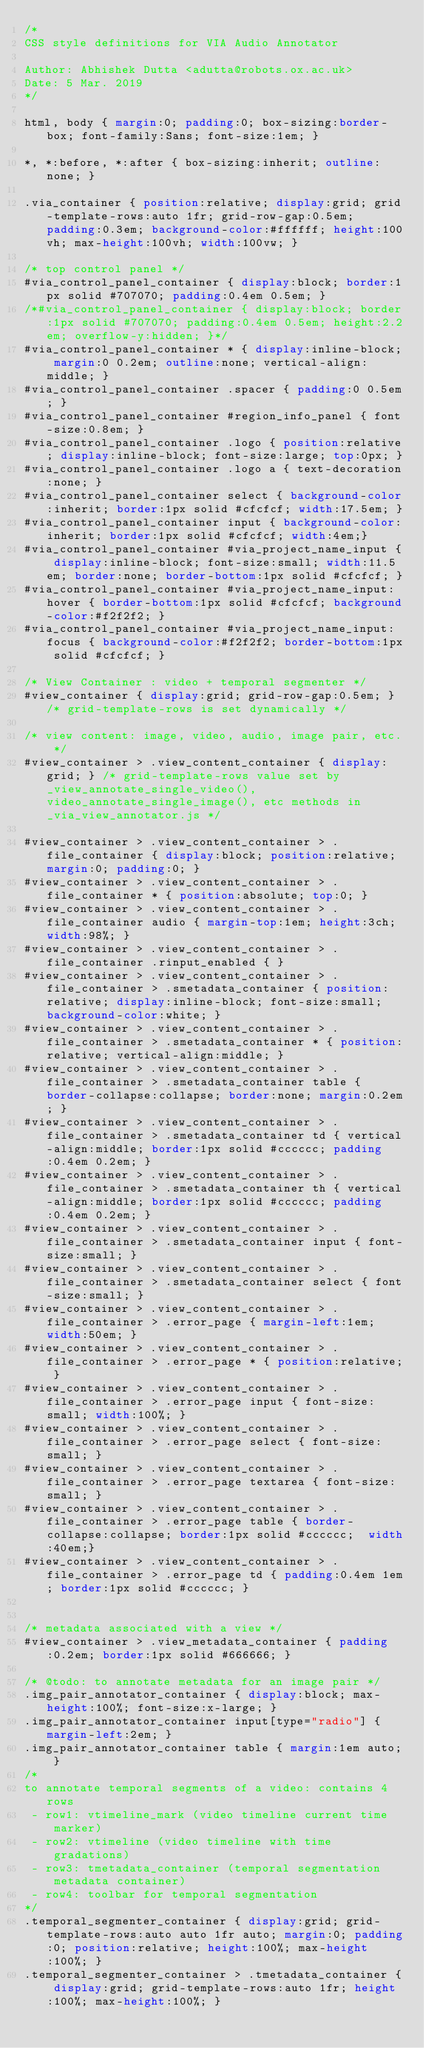<code> <loc_0><loc_0><loc_500><loc_500><_CSS_>/*
CSS style definitions for VIA Audio Annotator

Author: Abhishek Dutta <adutta@robots.ox.ac.uk>
Date: 5 Mar. 2019
*/

html, body { margin:0; padding:0; box-sizing:border-box; font-family:Sans; font-size:1em; }

*, *:before, *:after { box-sizing:inherit; outline:none; }

.via_container { position:relative; display:grid; grid-template-rows:auto 1fr; grid-row-gap:0.5em; padding:0.3em; background-color:#ffffff; height:100vh; max-height:100vh; width:100vw; }

/* top control panel */
#via_control_panel_container { display:block; border:1px solid #707070; padding:0.4em 0.5em; }
/*#via_control_panel_container { display:block; border:1px solid #707070; padding:0.4em 0.5em; height:2.2em; overflow-y:hidden; }*/
#via_control_panel_container * { display:inline-block; margin:0 0.2em; outline:none; vertical-align:middle; }
#via_control_panel_container .spacer { padding:0 0.5em; }
#via_control_panel_container #region_info_panel { font-size:0.8em; }
#via_control_panel_container .logo { position:relative; display:inline-block; font-size:large; top:0px; }
#via_control_panel_container .logo a { text-decoration:none; }
#via_control_panel_container select { background-color:inherit; border:1px solid #cfcfcf; width:17.5em; }
#via_control_panel_container input { background-color:inherit; border:1px solid #cfcfcf; width:4em;}
#via_control_panel_container #via_project_name_input { display:inline-block; font-size:small; width:11.5em; border:none; border-bottom:1px solid #cfcfcf; }
#via_control_panel_container #via_project_name_input:hover { border-bottom:1px solid #cfcfcf; background-color:#f2f2f2; }
#via_control_panel_container #via_project_name_input:focus { background-color:#f2f2f2; border-bottom:1px solid #cfcfcf; }

/* View Container : video + temporal segmenter */
#view_container { display:grid; grid-row-gap:0.5em; } /* grid-template-rows is set dynamically */

/* view content: image, video, audio, image pair, etc. */
#view_container > .view_content_container { display:grid; } /* grid-template-rows value set by _view_annotate_single_video(), video_annotate_single_image(), etc methods in _via_view_annotator.js */

#view_container > .view_content_container > .file_container { display:block; position:relative; margin:0; padding:0; }
#view_container > .view_content_container > .file_container * { position:absolute; top:0; }
#view_container > .view_content_container > .file_container audio { margin-top:1em; height:3ch; width:98%; }
#view_container > .view_content_container > .file_container .rinput_enabled { }
#view_container > .view_content_container > .file_container > .smetadata_container { position:relative; display:inline-block; font-size:small; background-color:white; }
#view_container > .view_content_container > .file_container > .smetadata_container * { position:relative; vertical-align:middle; }
#view_container > .view_content_container > .file_container > .smetadata_container table { border-collapse:collapse; border:none; margin:0.2em; }
#view_container > .view_content_container > .file_container > .smetadata_container td { vertical-align:middle; border:1px solid #cccccc; padding:0.4em 0.2em; }
#view_container > .view_content_container > .file_container > .smetadata_container th { vertical-align:middle; border:1px solid #cccccc; padding:0.4em 0.2em; }
#view_container > .view_content_container > .file_container > .smetadata_container input { font-size:small; }
#view_container > .view_content_container > .file_container > .smetadata_container select { font-size:small; }
#view_container > .view_content_container > .file_container > .error_page { margin-left:1em; width:50em; }
#view_container > .view_content_container > .file_container > .error_page * { position:relative; }
#view_container > .view_content_container > .file_container > .error_page input { font-size:small; width:100%; }
#view_container > .view_content_container > .file_container > .error_page select { font-size:small; }
#view_container > .view_content_container > .file_container > .error_page textarea { font-size:small; }
#view_container > .view_content_container > .file_container > .error_page table { border-collapse:collapse; border:1px solid #cccccc;  width:40em;}
#view_container > .view_content_container > .file_container > .error_page td { padding:0.4em 1em; border:1px solid #cccccc; }


/* metadata associated with a view */
#view_container > .view_metadata_container { padding:0.2em; border:1px solid #666666; }

/* @todo: to annotate metadata for an image pair */
.img_pair_annotator_container { display:block; max-height:100%; font-size:x-large; }
.img_pair_annotator_container input[type="radio"] { margin-left:2em; }
.img_pair_annotator_container table { margin:1em auto; }
/*
to annotate temporal segments of a video: contains 4 rows
 - row1: vtimeline_mark (video timeline current time marker)
 - row2: vtimeline (video timeline with time gradations)
 - row3: tmetadata_container (temporal segmentation metadata container)
 - row4: toolbar for temporal segmentation
*/
.temporal_segmenter_container { display:grid; grid-template-rows:auto auto 1fr auto; margin:0; padding:0; position:relative; height:100%; max-height:100%; }
.temporal_segmenter_container > .tmetadata_container { display:grid; grid-template-rows:auto 1fr; height:100%; max-height:100%; }
</code> 